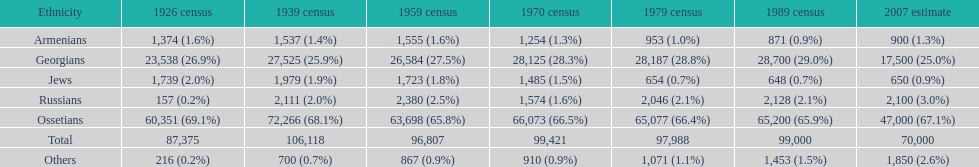I'm looking to parse the entire table for insights. Could you assist me with that? {'header': ['Ethnicity', '1926 census', '1939 census', '1959 census', '1970 census', '1979 census', '1989 census', '2007 estimate'], 'rows': [['Armenians', '1,374 (1.6%)', '1,537 (1.4%)', '1,555 (1.6%)', '1,254 (1.3%)', '953 (1.0%)', '871 (0.9%)', '900 (1.3%)'], ['Georgians', '23,538 (26.9%)', '27,525 (25.9%)', '26,584 (27.5%)', '28,125 (28.3%)', '28,187 (28.8%)', '28,700 (29.0%)', '17,500 (25.0%)'], ['Jews', '1,739 (2.0%)', '1,979 (1.9%)', '1,723 (1.8%)', '1,485 (1.5%)', '654 (0.7%)', '648 (0.7%)', '650 (0.9%)'], ['Russians', '157 (0.2%)', '2,111 (2.0%)', '2,380 (2.5%)', '1,574 (1.6%)', '2,046 (2.1%)', '2,128 (2.1%)', '2,100 (3.0%)'], ['Ossetians', '60,351 (69.1%)', '72,266 (68.1%)', '63,698 (65.8%)', '66,073 (66.5%)', '65,077 (66.4%)', '65,200 (65.9%)', '47,000 (67.1%)'], ['Total', '87,375', '106,118', '96,807', '99,421', '97,988', '99,000', '70,000'], ['Others', '216 (0.2%)', '700 (0.7%)', '867 (0.9%)', '910 (0.9%)', '1,071 (1.1%)', '1,453 (1.5%)', '1,850 (2.6%)']]} How many russians lived in south ossetia in 1970? 1,574. 